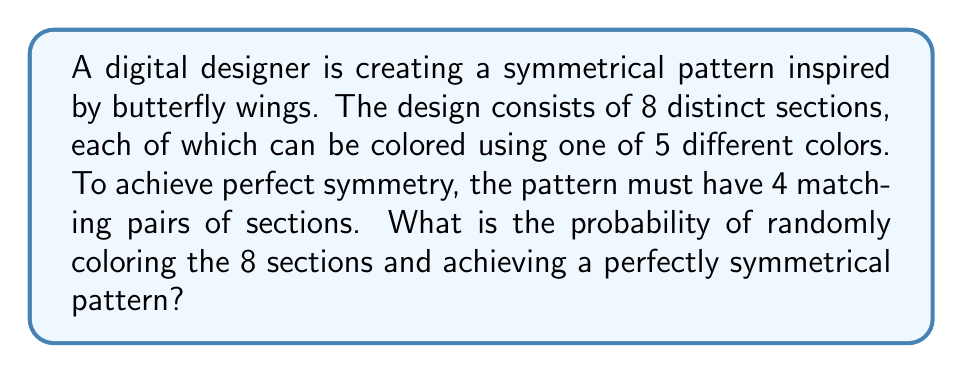Provide a solution to this math problem. Let's approach this step-by-step:

1) First, we need to understand what constitutes a symmetrical pattern in this context. We need 4 pairs of matching sections.

2) To calculate the probability, we'll use the following approach:
   (Favorable outcomes) / (Total possible outcomes)

3) Total possible outcomes:
   There are 5 color choices for each of the 8 sections.
   Total outcomes = $5^8 = 390,625$

4) Favorable outcomes:
   a) We need to choose colors for 4 sections (half of the pattern).
      This can be done in $5^4 = 625$ ways.
   
   b) For each of these 625 colorings of half the pattern, there's only one way to color the other half to make it symmetrical.

   c) However, these 4 pairs can be arranged in $\frac{8!}{(2!)^4 \cdot 4!} = 105$ ways.

5) Therefore, favorable outcomes = $625 \cdot 105 = 65,625$

6) The probability is thus:

   $$P(\text{symmetrical pattern}) = \frac{65,625}{390,625} = \frac{1}{6}$$
Answer: $\frac{1}{6}$ 